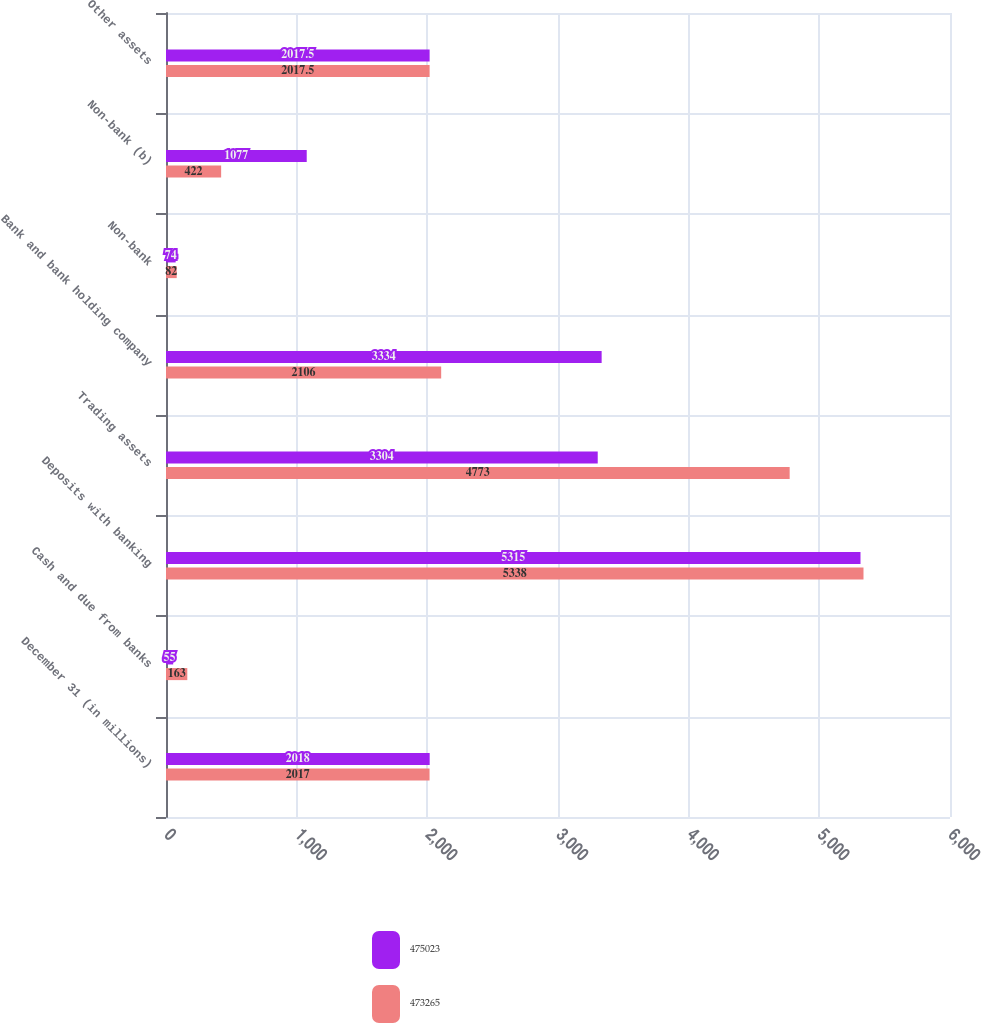<chart> <loc_0><loc_0><loc_500><loc_500><stacked_bar_chart><ecel><fcel>December 31 (in millions)<fcel>Cash and due from banks<fcel>Deposits with banking<fcel>Trading assets<fcel>Bank and bank holding company<fcel>Non-bank<fcel>Non-bank (b)<fcel>Other assets<nl><fcel>475023<fcel>2018<fcel>55<fcel>5315<fcel>3304<fcel>3334<fcel>74<fcel>1077<fcel>2017.5<nl><fcel>473265<fcel>2017<fcel>163<fcel>5338<fcel>4773<fcel>2106<fcel>82<fcel>422<fcel>2017.5<nl></chart> 